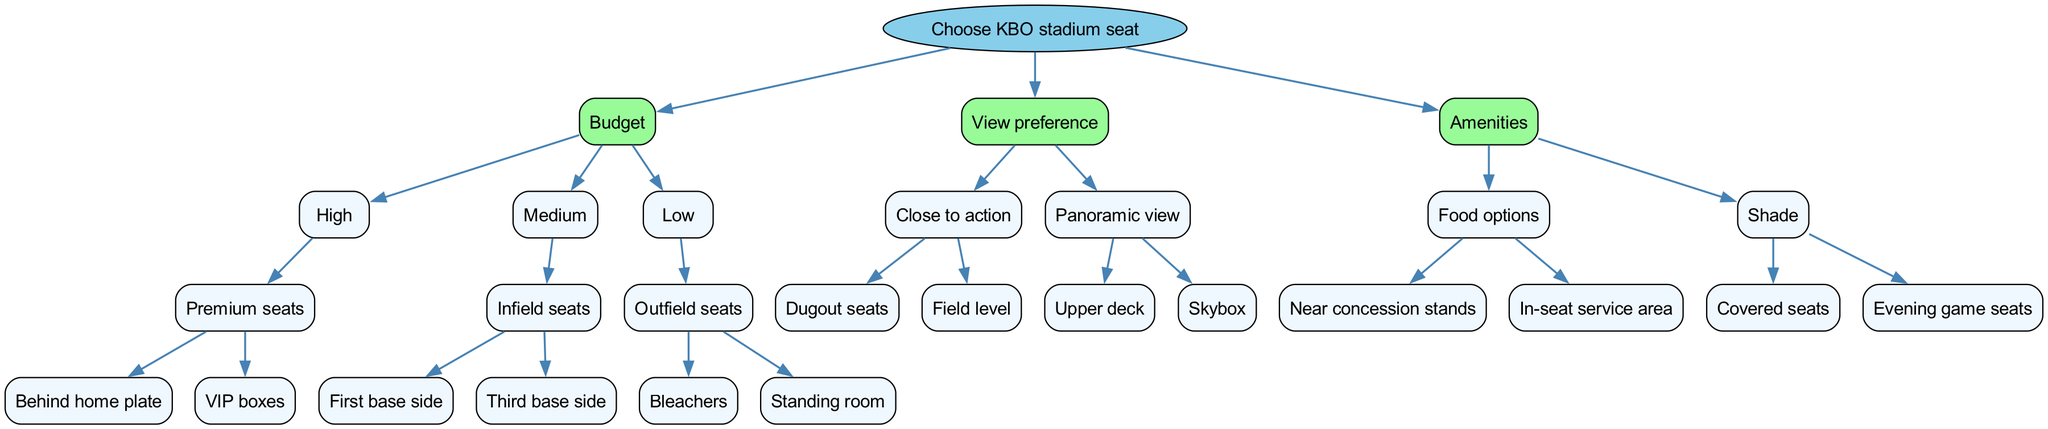What is the root node of the diagram? The root node is the starting point of the decision tree, which represents the main inquiry. In this case, it clearly states "Choose KBO stadium seat" as the root node of the decision tree.
Answer: Choose KBO stadium seat How many main categories are there at the first level? The first level after the root node has three main categories: Budget, View preference, and Amenities. By counting these categories, we find that there are three distinct nodes.
Answer: 3 What are the two options under the high budget category? The high budget category branches into two specific seating options: "Premium seats" includes "Behind home plate" and "VIP boxes." So, both are considered the options under this specific budget category.
Answer: Premium seats: Behind home plate, VIP boxes Which type of view preference allows for a close view of the action? The preference that allows for a close view of the action is categorized under "Close to action" and comes with two options: "Dugout seats" and "Field level." Both give excellent visibility of the game.
Answer: Close to action: Dugout seats, Field level If someone wants to enjoy food options while watching, what seating category should they prefer? To enjoy food options, they should look for seating under the "Amenities" category focused on "Food options," which includes the choices "Near concession stands" and "In-seat service area." This way, they can have access to food while enjoying the game.
Answer: Food options: Near concession stands, In-seat service area What distinguishes the "Evening game seats"? These seats fall under the "Shade" category of amenities and provide relief from direct sunlight during evening games, allowing for a more comfortable viewing experience compared to other options.
Answer: Evening game seats How many total nodes are shown under the "Low" budget category? The "Low" budget category has two child nodes: "Outfield seats," which branches into "Bleachers" and "Standing room." By tallying these, we find there are three distinct nodes under the "Low" budget category.
Answer: 3 Which seating provides a panoramic view? The seating options that provide a panoramic view fall under the "View preference" category labeled "Panoramic view," and include "Upper deck" and "Skybox." This option is ideal for those looking for a wider perspective on the game.
Answer: Panoramic view: Upper deck, Skybox What are the two types of seats that come with amenities offering shade? The amenities offering shade include two options: "Covered seats" and "Evening game seats," both designed to ensure that the audience is well-protected from harsh sunlight.
Answer: Covered seats, Evening game seats 